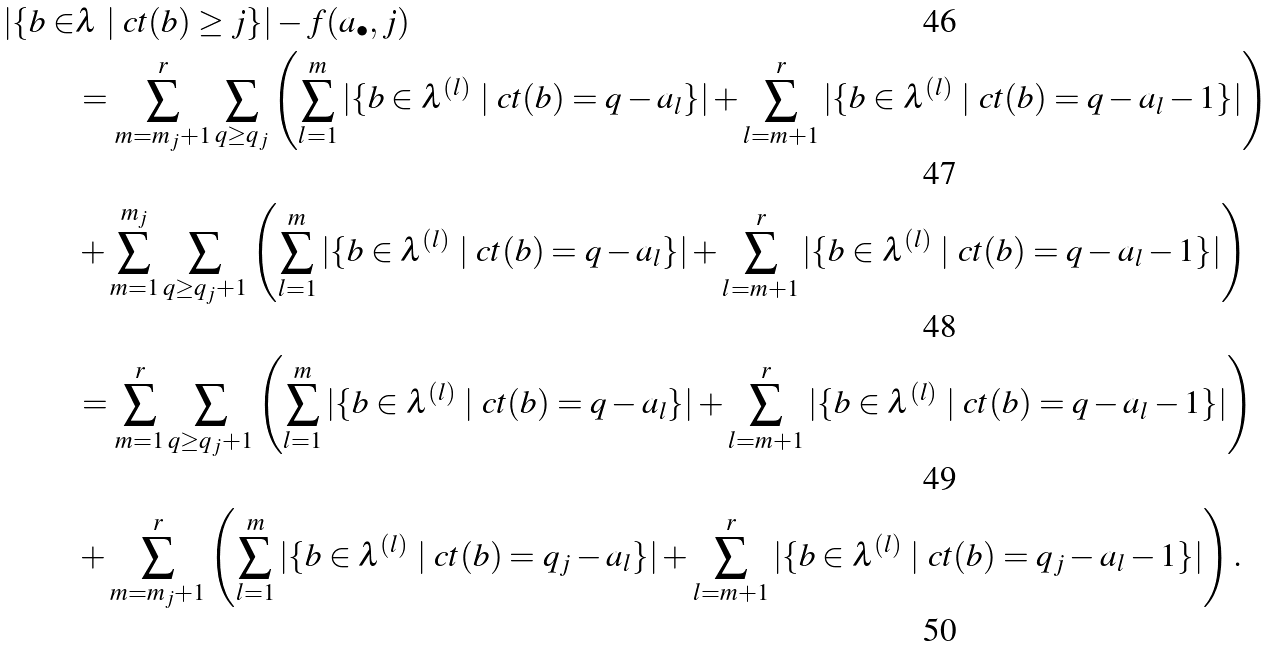<formula> <loc_0><loc_0><loc_500><loc_500>| \{ b \in & \lambda \ | \ c t ( b ) \geq j \} | - f ( a _ { \bullet } , j ) \\ & = \sum _ { m = m _ { j } + 1 } ^ { r } \sum _ { q \geq q _ { j } } \left ( \sum _ { l = 1 } ^ { m } | \{ b \in \lambda ^ { ( l ) } \ | \ c t ( b ) = q - a _ { l } \} | + \sum _ { l = m + 1 } ^ { r } | \{ b \in \lambda ^ { ( l ) } \ | \ c t ( b ) = q - a _ { l } - 1 \} | \right ) \\ & + \sum _ { m = 1 } ^ { m _ { j } } \sum _ { q \geq q _ { j } + 1 } \left ( \sum _ { l = 1 } ^ { m } | \{ b \in \lambda ^ { ( l ) } \ | \ c t ( b ) = q - a _ { l } \} | + \sum _ { l = m + 1 } ^ { r } | \{ b \in \lambda ^ { ( l ) } \ | \ c t ( b ) = q - a _ { l } - 1 \} | \right ) \\ & = \sum _ { m = 1 } ^ { r } \sum _ { q \geq q _ { j } + 1 } \left ( \sum _ { l = 1 } ^ { m } | \{ b \in \lambda ^ { ( l ) } \ | \ c t ( b ) = q - a _ { l } \} | + \sum _ { l = m + 1 } ^ { r } | \{ b \in \lambda ^ { ( l ) } \ | \ c t ( b ) = q - a _ { l } - 1 \} | \right ) \\ & + \sum _ { m = m _ { j } + 1 } ^ { r } \left ( \sum _ { l = 1 } ^ { m } | \{ b \in \lambda ^ { ( l ) } \ | \ c t ( b ) = q _ { j } - a _ { l } \} | + \sum _ { l = m + 1 } ^ { r } | \{ b \in \lambda ^ { ( l ) } \ | \ c t ( b ) = q _ { j } - a _ { l } - 1 \} | \right ) .</formula> 